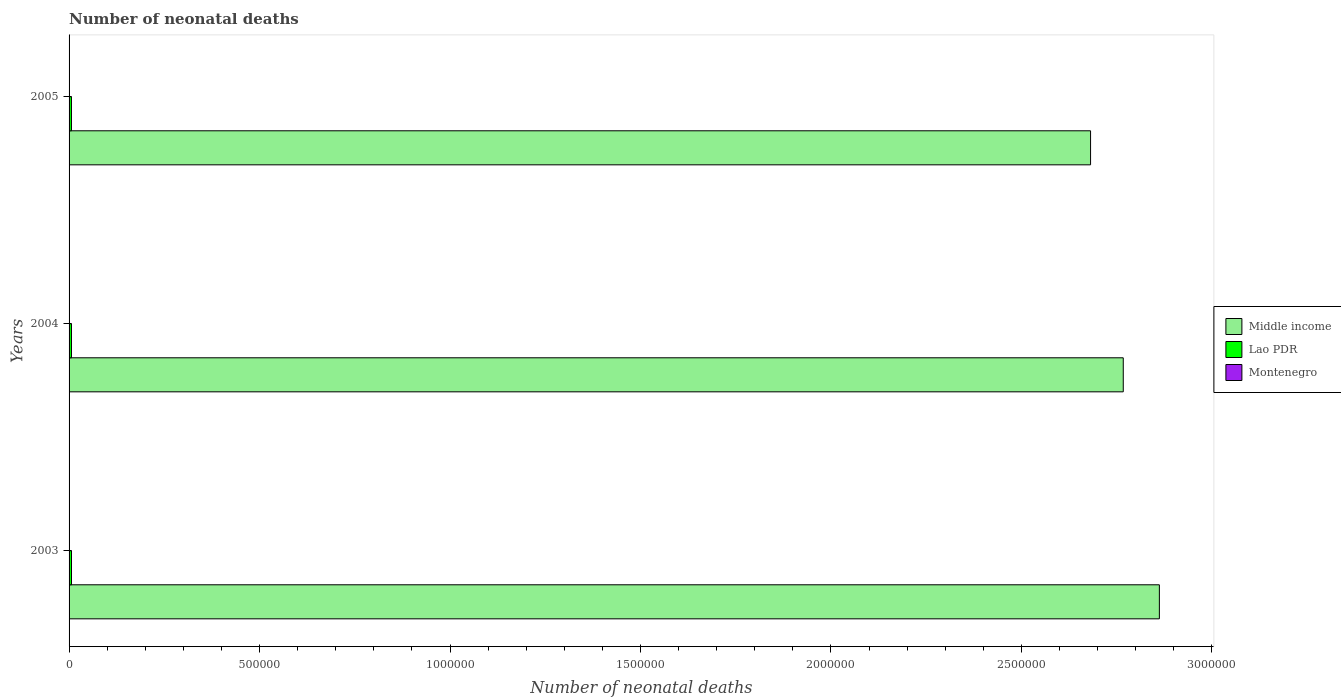How many groups of bars are there?
Your response must be concise. 3. Are the number of bars on each tick of the Y-axis equal?
Offer a terse response. Yes. What is the label of the 1st group of bars from the top?
Offer a very short reply. 2005. In how many cases, is the number of bars for a given year not equal to the number of legend labels?
Your response must be concise. 0. What is the number of neonatal deaths in in Lao PDR in 2005?
Give a very brief answer. 6251. Across all years, what is the maximum number of neonatal deaths in in Montenegro?
Your response must be concise. 64. Across all years, what is the minimum number of neonatal deaths in in Middle income?
Offer a very short reply. 2.68e+06. In which year was the number of neonatal deaths in in Montenegro maximum?
Your answer should be very brief. 2003. In which year was the number of neonatal deaths in in Lao PDR minimum?
Make the answer very short. 2005. What is the total number of neonatal deaths in in Lao PDR in the graph?
Your answer should be compact. 1.89e+04. What is the difference between the number of neonatal deaths in in Lao PDR in 2003 and that in 2005?
Provide a short and direct response. 115. What is the difference between the number of neonatal deaths in in Lao PDR in 2004 and the number of neonatal deaths in in Middle income in 2005?
Ensure brevity in your answer.  -2.68e+06. What is the average number of neonatal deaths in in Montenegro per year?
Give a very brief answer. 60.33. In the year 2005, what is the difference between the number of neonatal deaths in in Lao PDR and number of neonatal deaths in in Middle income?
Offer a terse response. -2.68e+06. In how many years, is the number of neonatal deaths in in Lao PDR greater than 200000 ?
Ensure brevity in your answer.  0. What is the ratio of the number of neonatal deaths in in Montenegro in 2003 to that in 2005?
Your answer should be very brief. 1.14. Is the difference between the number of neonatal deaths in in Lao PDR in 2004 and 2005 greater than the difference between the number of neonatal deaths in in Middle income in 2004 and 2005?
Ensure brevity in your answer.  No. What is the difference between the highest and the second highest number of neonatal deaths in in Middle income?
Ensure brevity in your answer.  9.48e+04. What is the difference between the highest and the lowest number of neonatal deaths in in Montenegro?
Ensure brevity in your answer.  8. In how many years, is the number of neonatal deaths in in Lao PDR greater than the average number of neonatal deaths in in Lao PDR taken over all years?
Offer a terse response. 1. Is the sum of the number of neonatal deaths in in Middle income in 2003 and 2005 greater than the maximum number of neonatal deaths in in Montenegro across all years?
Provide a short and direct response. Yes. What does the 1st bar from the top in 2003 represents?
Provide a succinct answer. Montenegro. What does the 1st bar from the bottom in 2004 represents?
Offer a terse response. Middle income. How many bars are there?
Offer a terse response. 9. Are all the bars in the graph horizontal?
Provide a short and direct response. Yes. What is the difference between two consecutive major ticks on the X-axis?
Provide a succinct answer. 5.00e+05. How many legend labels are there?
Ensure brevity in your answer.  3. How are the legend labels stacked?
Your answer should be very brief. Vertical. What is the title of the graph?
Your response must be concise. Number of neonatal deaths. What is the label or title of the X-axis?
Your answer should be very brief. Number of neonatal deaths. What is the label or title of the Y-axis?
Your response must be concise. Years. What is the Number of neonatal deaths in Middle income in 2003?
Your response must be concise. 2.86e+06. What is the Number of neonatal deaths of Lao PDR in 2003?
Make the answer very short. 6366. What is the Number of neonatal deaths of Middle income in 2004?
Offer a terse response. 2.77e+06. What is the Number of neonatal deaths in Lao PDR in 2004?
Provide a short and direct response. 6288. What is the Number of neonatal deaths of Middle income in 2005?
Ensure brevity in your answer.  2.68e+06. What is the Number of neonatal deaths of Lao PDR in 2005?
Keep it short and to the point. 6251. Across all years, what is the maximum Number of neonatal deaths of Middle income?
Your answer should be compact. 2.86e+06. Across all years, what is the maximum Number of neonatal deaths of Lao PDR?
Provide a short and direct response. 6366. Across all years, what is the maximum Number of neonatal deaths of Montenegro?
Your answer should be very brief. 64. Across all years, what is the minimum Number of neonatal deaths of Middle income?
Your response must be concise. 2.68e+06. Across all years, what is the minimum Number of neonatal deaths of Lao PDR?
Offer a very short reply. 6251. What is the total Number of neonatal deaths in Middle income in the graph?
Make the answer very short. 8.31e+06. What is the total Number of neonatal deaths of Lao PDR in the graph?
Ensure brevity in your answer.  1.89e+04. What is the total Number of neonatal deaths of Montenegro in the graph?
Keep it short and to the point. 181. What is the difference between the Number of neonatal deaths of Middle income in 2003 and that in 2004?
Your answer should be compact. 9.48e+04. What is the difference between the Number of neonatal deaths of Middle income in 2003 and that in 2005?
Offer a very short reply. 1.81e+05. What is the difference between the Number of neonatal deaths of Lao PDR in 2003 and that in 2005?
Your answer should be very brief. 115. What is the difference between the Number of neonatal deaths in Montenegro in 2003 and that in 2005?
Your answer should be compact. 8. What is the difference between the Number of neonatal deaths in Middle income in 2004 and that in 2005?
Keep it short and to the point. 8.58e+04. What is the difference between the Number of neonatal deaths of Lao PDR in 2004 and that in 2005?
Offer a terse response. 37. What is the difference between the Number of neonatal deaths in Middle income in 2003 and the Number of neonatal deaths in Lao PDR in 2004?
Your answer should be very brief. 2.86e+06. What is the difference between the Number of neonatal deaths of Middle income in 2003 and the Number of neonatal deaths of Montenegro in 2004?
Make the answer very short. 2.86e+06. What is the difference between the Number of neonatal deaths of Lao PDR in 2003 and the Number of neonatal deaths of Montenegro in 2004?
Make the answer very short. 6305. What is the difference between the Number of neonatal deaths of Middle income in 2003 and the Number of neonatal deaths of Lao PDR in 2005?
Your answer should be very brief. 2.86e+06. What is the difference between the Number of neonatal deaths in Middle income in 2003 and the Number of neonatal deaths in Montenegro in 2005?
Your response must be concise. 2.86e+06. What is the difference between the Number of neonatal deaths in Lao PDR in 2003 and the Number of neonatal deaths in Montenegro in 2005?
Offer a very short reply. 6310. What is the difference between the Number of neonatal deaths of Middle income in 2004 and the Number of neonatal deaths of Lao PDR in 2005?
Provide a succinct answer. 2.76e+06. What is the difference between the Number of neonatal deaths of Middle income in 2004 and the Number of neonatal deaths of Montenegro in 2005?
Offer a terse response. 2.77e+06. What is the difference between the Number of neonatal deaths in Lao PDR in 2004 and the Number of neonatal deaths in Montenegro in 2005?
Keep it short and to the point. 6232. What is the average Number of neonatal deaths in Middle income per year?
Your answer should be very brief. 2.77e+06. What is the average Number of neonatal deaths in Lao PDR per year?
Keep it short and to the point. 6301.67. What is the average Number of neonatal deaths of Montenegro per year?
Offer a very short reply. 60.33. In the year 2003, what is the difference between the Number of neonatal deaths in Middle income and Number of neonatal deaths in Lao PDR?
Offer a very short reply. 2.86e+06. In the year 2003, what is the difference between the Number of neonatal deaths in Middle income and Number of neonatal deaths in Montenegro?
Your answer should be compact. 2.86e+06. In the year 2003, what is the difference between the Number of neonatal deaths in Lao PDR and Number of neonatal deaths in Montenegro?
Provide a short and direct response. 6302. In the year 2004, what is the difference between the Number of neonatal deaths of Middle income and Number of neonatal deaths of Lao PDR?
Your answer should be compact. 2.76e+06. In the year 2004, what is the difference between the Number of neonatal deaths in Middle income and Number of neonatal deaths in Montenegro?
Your answer should be very brief. 2.77e+06. In the year 2004, what is the difference between the Number of neonatal deaths in Lao PDR and Number of neonatal deaths in Montenegro?
Provide a succinct answer. 6227. In the year 2005, what is the difference between the Number of neonatal deaths in Middle income and Number of neonatal deaths in Lao PDR?
Your response must be concise. 2.68e+06. In the year 2005, what is the difference between the Number of neonatal deaths in Middle income and Number of neonatal deaths in Montenegro?
Provide a short and direct response. 2.68e+06. In the year 2005, what is the difference between the Number of neonatal deaths in Lao PDR and Number of neonatal deaths in Montenegro?
Your response must be concise. 6195. What is the ratio of the Number of neonatal deaths of Middle income in 2003 to that in 2004?
Offer a very short reply. 1.03. What is the ratio of the Number of neonatal deaths in Lao PDR in 2003 to that in 2004?
Offer a very short reply. 1.01. What is the ratio of the Number of neonatal deaths of Montenegro in 2003 to that in 2004?
Offer a terse response. 1.05. What is the ratio of the Number of neonatal deaths in Middle income in 2003 to that in 2005?
Ensure brevity in your answer.  1.07. What is the ratio of the Number of neonatal deaths of Lao PDR in 2003 to that in 2005?
Make the answer very short. 1.02. What is the ratio of the Number of neonatal deaths in Montenegro in 2003 to that in 2005?
Your response must be concise. 1.14. What is the ratio of the Number of neonatal deaths in Middle income in 2004 to that in 2005?
Your answer should be compact. 1.03. What is the ratio of the Number of neonatal deaths in Lao PDR in 2004 to that in 2005?
Ensure brevity in your answer.  1.01. What is the ratio of the Number of neonatal deaths of Montenegro in 2004 to that in 2005?
Your answer should be compact. 1.09. What is the difference between the highest and the second highest Number of neonatal deaths of Middle income?
Provide a succinct answer. 9.48e+04. What is the difference between the highest and the second highest Number of neonatal deaths in Lao PDR?
Offer a very short reply. 78. What is the difference between the highest and the second highest Number of neonatal deaths in Montenegro?
Give a very brief answer. 3. What is the difference between the highest and the lowest Number of neonatal deaths in Middle income?
Your response must be concise. 1.81e+05. What is the difference between the highest and the lowest Number of neonatal deaths of Lao PDR?
Give a very brief answer. 115. 